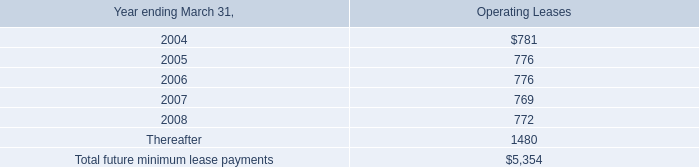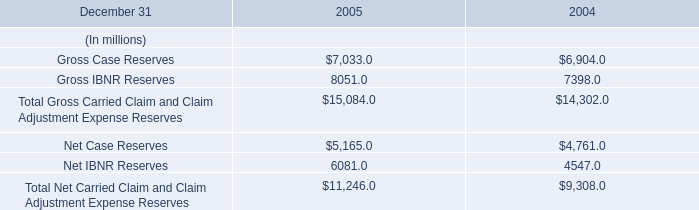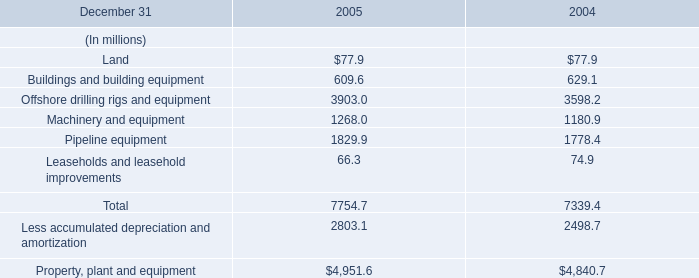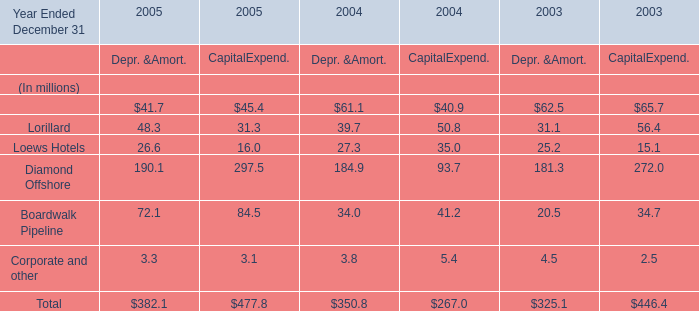What's the sum of Offshore drilling rigs and equipment of 2004, Net Case Reserves of 2005, and Pipeline equipment of 2005 ? 
Computations: ((3598.2 + 5165.0) + 1829.9)
Answer: 10593.1. 